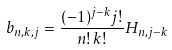<formula> <loc_0><loc_0><loc_500><loc_500>b _ { n , k , j } = \frac { ( - 1 ) ^ { j - k } j ! } { n ! \, k ! } H _ { n , j - k }</formula> 